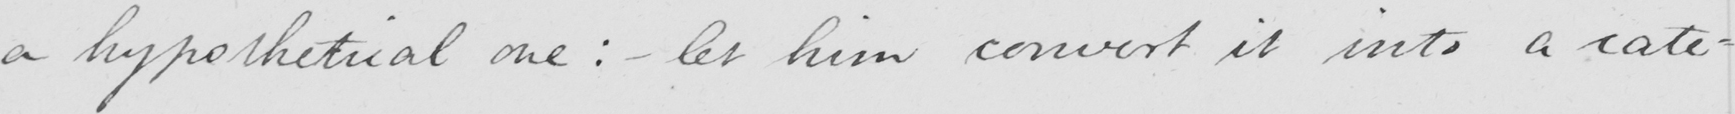What text is written in this handwritten line? a hypothetical one :  - let him convert it into a cate- 